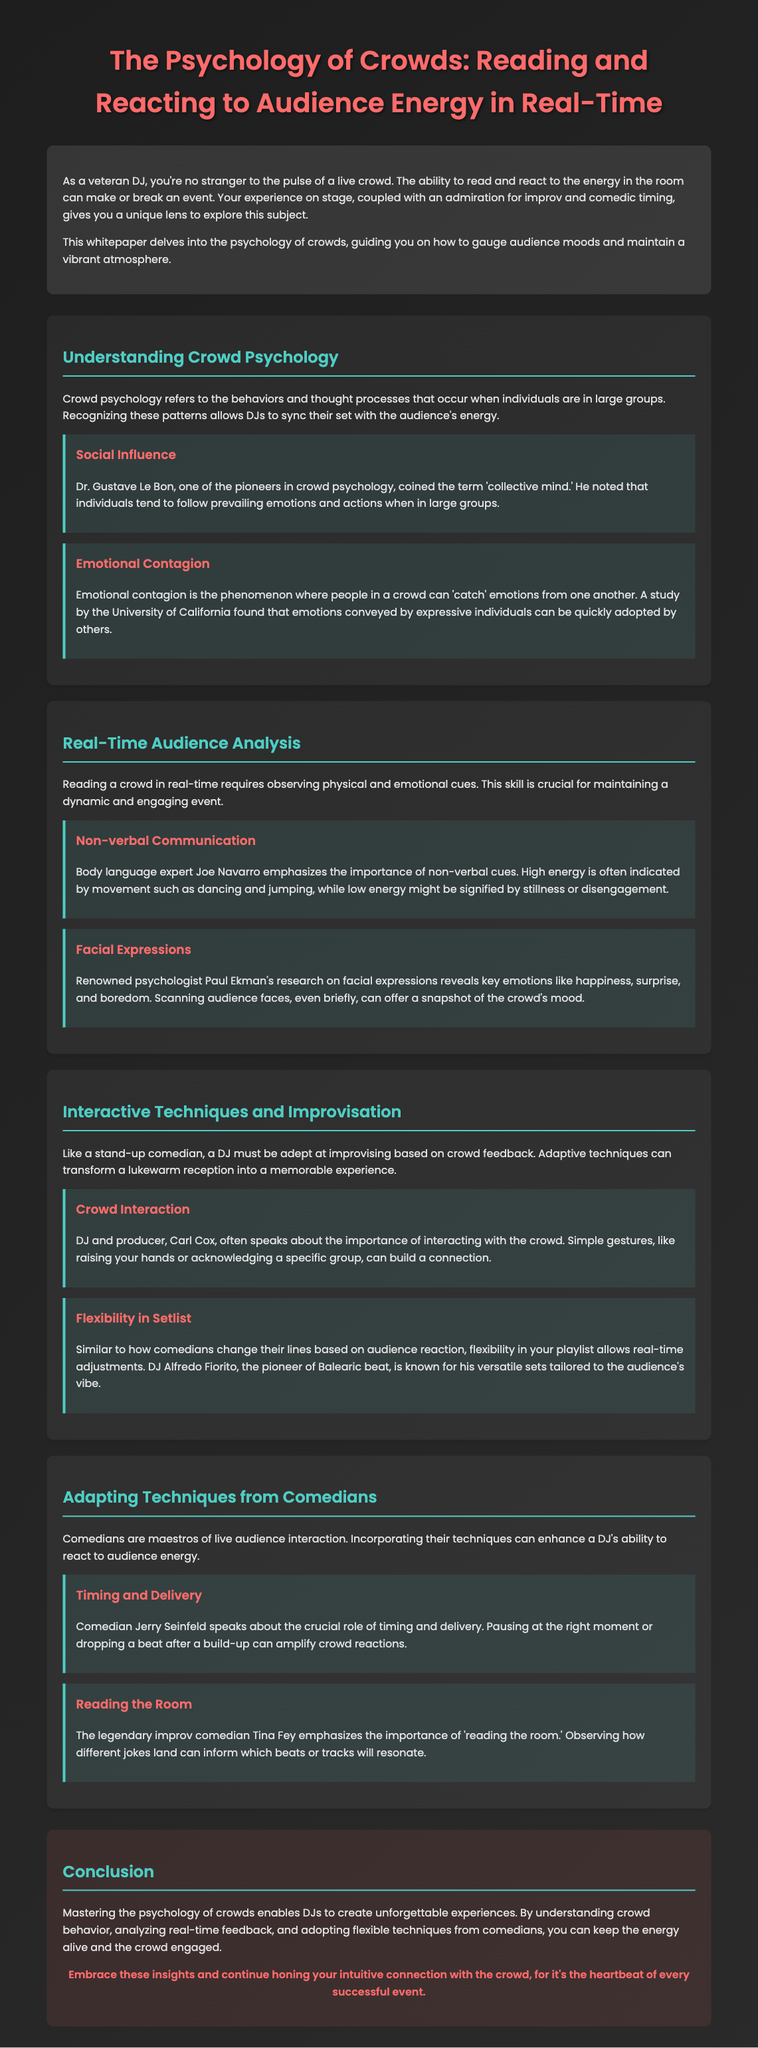what is the title of the whitepaper? The title of the whitepaper is found at the top of the document.
Answer: The Psychology of Crowds: Reading and Reacting to Audience Energy in Real-Time who coined the term 'collective mind'? The document mentions Dr. Gustave Le Bon as the individual who coined this term in crowd psychology.
Answer: Dr. Gustave Le Bon what phenomenon involves people 'catching' emotions from one another? The document describes 'emotional contagion' as the phenomenon where this occurs in crowds.
Answer: Emotional contagion which expert emphasizes the importance of non-verbal cues? The document references body language expert Joe Navarro regarding non-verbal communication.
Answer: Joe Navarro who often speaks about the importance of interacting with the crowd? The whitepaper cites DJ and producer Carl Cox as someone who emphasizes crowd interaction.
Answer: Carl Cox which comedian highlights the role of timing and delivery? Jerry Seinfeld is noted in the document for discussing the importance of timing and delivery in performance.
Answer: Jerry Seinfeld what is the key role of 'reading the room'? The document states that 'reading the room' helps a DJ understand which beats or tracks resonate well with the audience.
Answer: Understanding audience preferences how does flexibility in a playlist benefit a DJ? It allows DJs to make real-time adjustments based on the crowd's vibe, which is discussed under adaptive techniques.
Answer: Real-time adjustments 